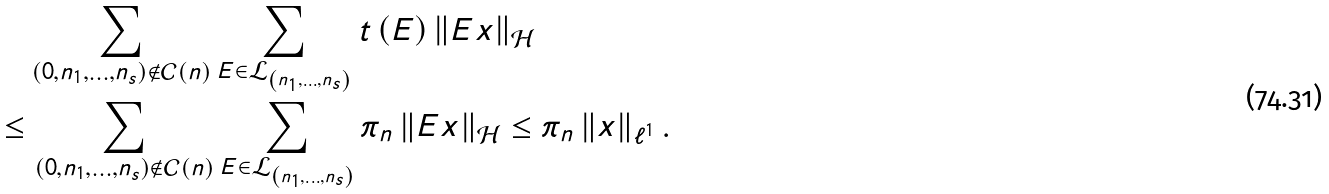<formula> <loc_0><loc_0><loc_500><loc_500>& \quad \sum _ { \left ( 0 , n _ { 1 } , \dots , n _ { s } \right ) \notin \mathcal { C } \left ( n \right ) } \sum _ { E \in \mathcal { L } _ { \left ( n _ { 1 } , \dots , n _ { s } \right ) } } t \left ( E \right ) \left \| E x \right \| _ { \mathcal { H } } \\ & \leq \sum _ { \left ( 0 , n _ { 1 } , \dots , n _ { s } \right ) \notin \mathcal { C } \left ( n \right ) } \sum _ { E \in \mathcal { L } _ { \left ( n _ { 1 } , \dots , n _ { s } \right ) } } \pi _ { n } \left \| E x \right \| _ { \mathcal { H } } \leq \pi _ { n } \left \| x \right \| _ { \ell ^ { 1 } } .</formula> 